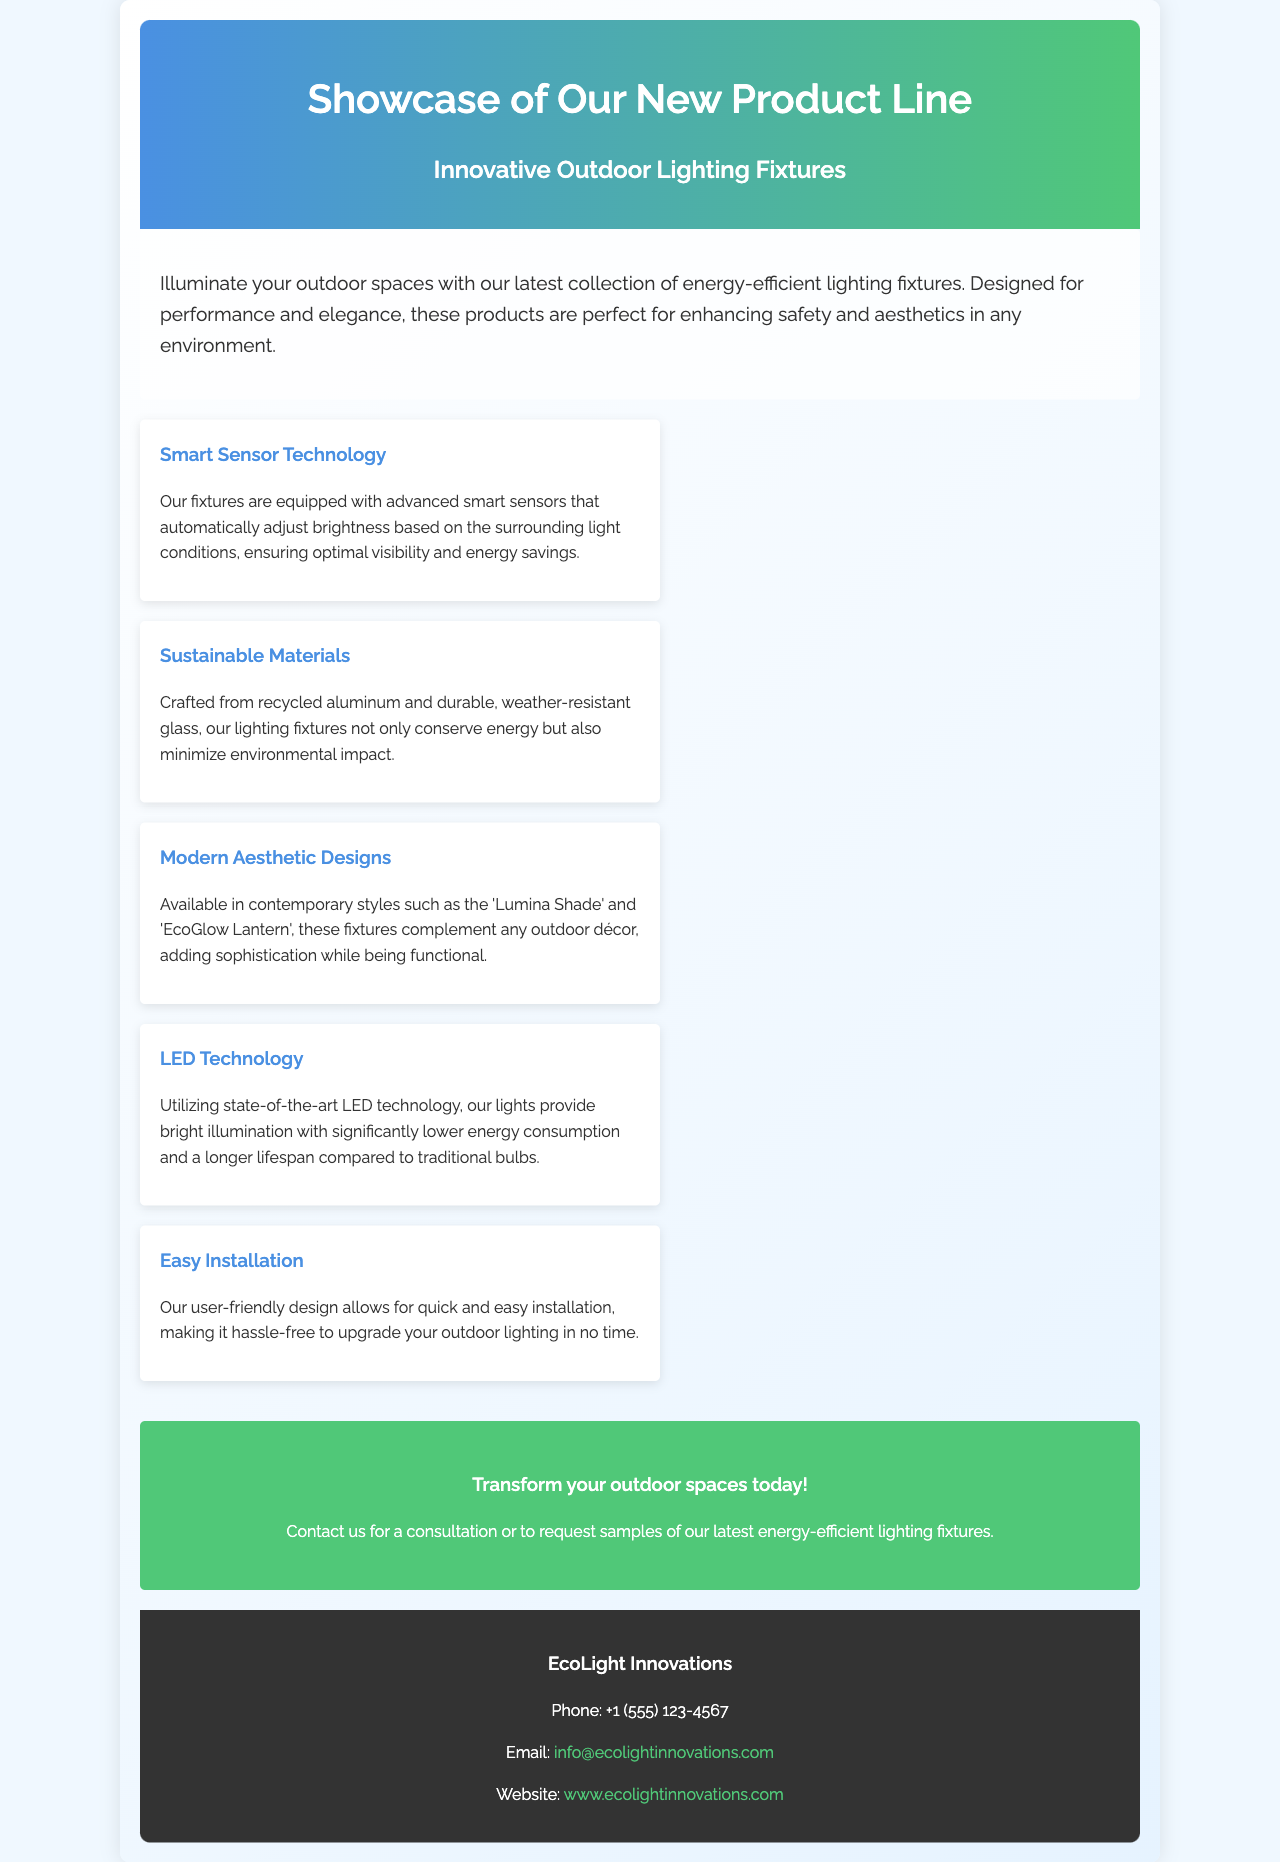What is the title of the brochure? The title of the brochure, as seen in the header, is "Showcase of Our New Product Line".
Answer: Showcase of Our New Product Line What type of technology does the new product line feature? The brochure highlights that the fixtures are equipped with "Smart Sensor Technology".
Answer: Smart Sensor Technology What materials are the lighting fixtures made from? The document specifies that the fixtures are crafted from "recycled aluminum and durable, weather-resistant glass".
Answer: recycled aluminum and durable, weather-resistant glass How can you contact EcoLight Innovations? The brochure provides various contact methods including a phone number, email, and website.
Answer: Phone, Email, Website What kind of installation does the new product line offer? The brochure states that these fixtures have a design that allows for "Easy Installation".
Answer: Easy Installation Which product style is mentioned in the brochure? The brochure lists contemporary styles including the "Lumina Shade" and "EcoGlow Lantern".
Answer: Lumina Shade, EcoGlow Lantern What is the primary purpose of the new product line? The introduction mentions that these products are perfect for "enhancing safety and aesthetics in any environment".
Answer: enhancing safety and aesthetics What LED technology advantage is highlighted? The document mentions that the lights provide "bright illumination with significantly lower energy consumption".
Answer: significantly lower energy consumption What is the suggested action for customers in the brochure? The call to action encourages customers to transform their outdoor spaces today and contact for consultations or samples.
Answer: Transform your outdoor spaces today! 